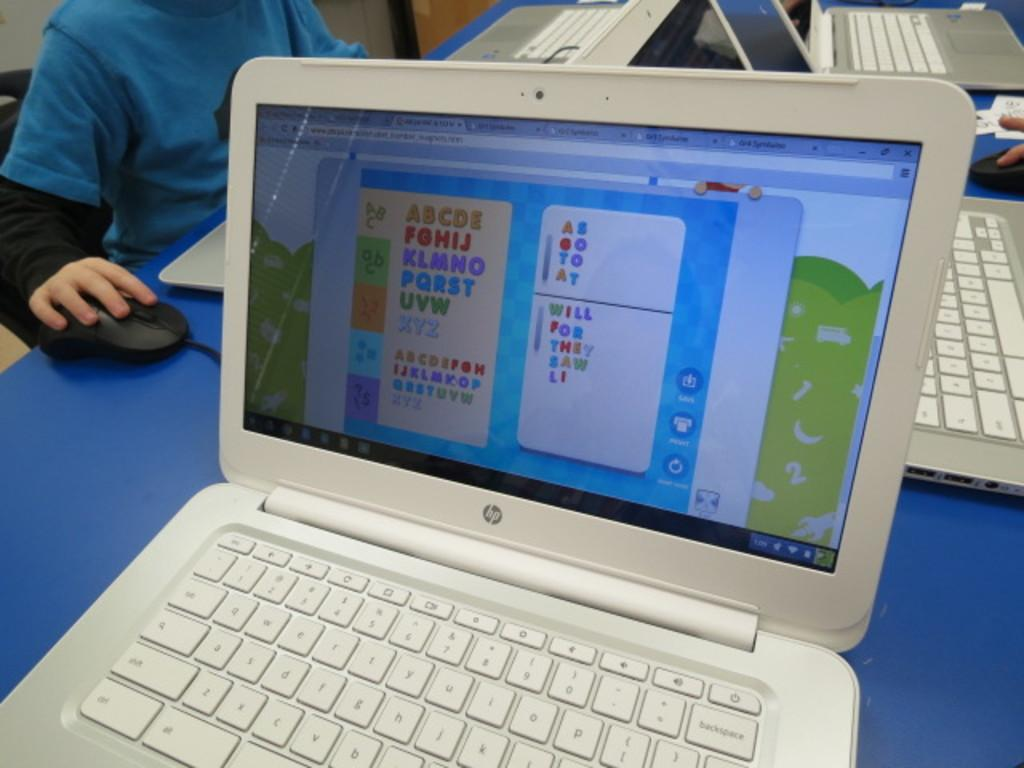<image>
Give a short and clear explanation of the subsequent image. A HP laptop displays a game using the alphabet. 